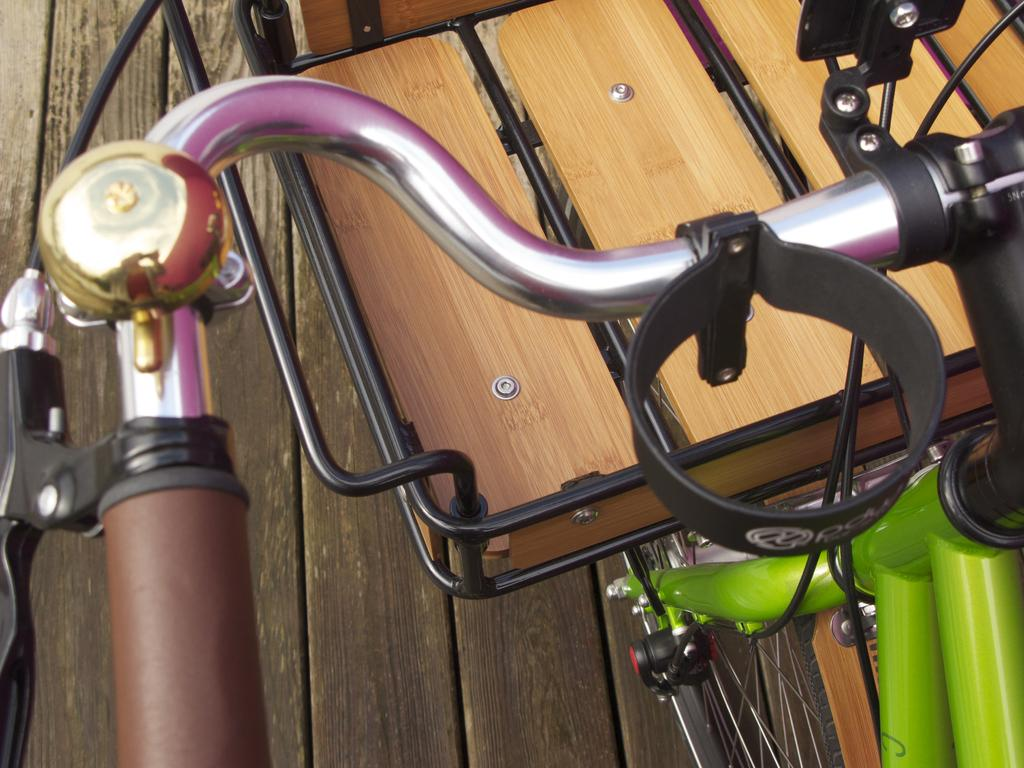What is the main object in the image? There is a bicycle in the image. What is attached to the front of the bicycle? There is a basket in front of the bicycle. What type of surface is the bicycle resting on? The bicycle is on a wooden surface. What type of machine is being celebrated in the image? There is no machine being celebrated in the image; it features a bicycle with a basket on a wooden surface. How does the bicycle maintain its balance in the image? The bicycle does not need to maintain its balance in the image, as it is stationary and resting on a wooden surface. 